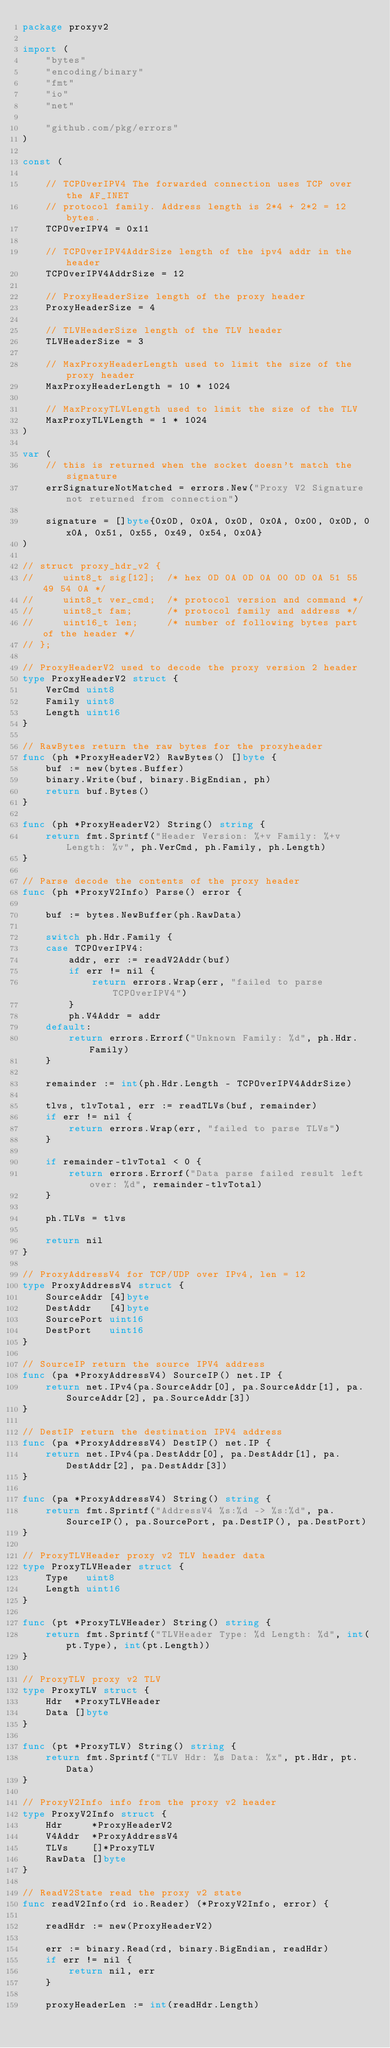Convert code to text. <code><loc_0><loc_0><loc_500><loc_500><_Go_>package proxyv2

import (
	"bytes"
	"encoding/binary"
	"fmt"
	"io"
	"net"

	"github.com/pkg/errors"
)

const (

	// TCPOverIPV4 The forwarded connection uses TCP over the AF_INET
	// protocol family. Address length is 2*4 + 2*2 = 12 bytes.
	TCPOverIPV4 = 0x11

	// TCPOverIPV4AddrSize length of the ipv4 addr in the header
	TCPOverIPV4AddrSize = 12

	// ProxyHeaderSize length of the proxy header
	ProxyHeaderSize = 4

	// TLVHeaderSize length of the TLV header
	TLVHeaderSize = 3

	// MaxProxyHeaderLength used to limit the size of the proxy header
	MaxProxyHeaderLength = 10 * 1024

	// MaxProxyTLVLength used to limit the size of the TLV
	MaxProxyTLVLength = 1 * 1024
)

var (
	// this is returned when the socket doesn't match the signature
	errSignatureNotMatched = errors.New("Proxy V2 Signature not returned from connection")

	signature = []byte{0x0D, 0x0A, 0x0D, 0x0A, 0x00, 0x0D, 0x0A, 0x51, 0x55, 0x49, 0x54, 0x0A}
)

// struct proxy_hdr_v2 {
//     uint8_t sig[12];  /* hex 0D 0A 0D 0A 00 0D 0A 51 55 49 54 0A */
//     uint8_t ver_cmd;  /* protocol version and command */
//     uint8_t fam;      /* protocol family and address */
//     uint16_t len;     /* number of following bytes part of the header */
// };

// ProxyHeaderV2 used to decode the proxy version 2 header
type ProxyHeaderV2 struct {
	VerCmd uint8
	Family uint8
	Length uint16
}

// RawBytes return the raw bytes for the proxyheader
func (ph *ProxyHeaderV2) RawBytes() []byte {
	buf := new(bytes.Buffer)
	binary.Write(buf, binary.BigEndian, ph)
	return buf.Bytes()
}

func (ph *ProxyHeaderV2) String() string {
	return fmt.Sprintf("Header Version: %+v Family: %+v Length: %v", ph.VerCmd, ph.Family, ph.Length)
}

// Parse decode the contents of the proxy header
func (ph *ProxyV2Info) Parse() error {

	buf := bytes.NewBuffer(ph.RawData)

	switch ph.Hdr.Family {
	case TCPOverIPV4:
		addr, err := readV2Addr(buf)
		if err != nil {
			return errors.Wrap(err, "failed to parse TCPOverIPV4")
		}
		ph.V4Addr = addr
	default:
		return errors.Errorf("Unknown Family: %d", ph.Hdr.Family)
	}

	remainder := int(ph.Hdr.Length - TCPOverIPV4AddrSize)

	tlvs, tlvTotal, err := readTLVs(buf, remainder)
	if err != nil {
		return errors.Wrap(err, "failed to parse TLVs")
	}

	if remainder-tlvTotal < 0 {
		return errors.Errorf("Data parse failed result left over: %d", remainder-tlvTotal)
	}

	ph.TLVs = tlvs

	return nil
}

// ProxyAddressV4 for TCP/UDP over IPv4, len = 12
type ProxyAddressV4 struct {
	SourceAddr [4]byte
	DestAddr   [4]byte
	SourcePort uint16
	DestPort   uint16
}

// SourceIP return the source IPV4 address
func (pa *ProxyAddressV4) SourceIP() net.IP {
	return net.IPv4(pa.SourceAddr[0], pa.SourceAddr[1], pa.SourceAddr[2], pa.SourceAddr[3])
}

// DestIP return the destination IPV4 address
func (pa *ProxyAddressV4) DestIP() net.IP {
	return net.IPv4(pa.DestAddr[0], pa.DestAddr[1], pa.DestAddr[2], pa.DestAddr[3])
}

func (pa *ProxyAddressV4) String() string {
	return fmt.Sprintf("AddressV4 %s:%d -> %s:%d", pa.SourceIP(), pa.SourcePort, pa.DestIP(), pa.DestPort)
}

// ProxyTLVHeader proxy v2 TLV header data
type ProxyTLVHeader struct {
	Type   uint8
	Length uint16
}

func (pt *ProxyTLVHeader) String() string {
	return fmt.Sprintf("TLVHeader Type: %d Length: %d", int(pt.Type), int(pt.Length))
}

// ProxyTLV proxy v2 TLV
type ProxyTLV struct {
	Hdr  *ProxyTLVHeader
	Data []byte
}

func (pt *ProxyTLV) String() string {
	return fmt.Sprintf("TLV Hdr: %s Data: %x", pt.Hdr, pt.Data)
}

// ProxyV2Info info from the proxy v2 header
type ProxyV2Info struct {
	Hdr     *ProxyHeaderV2
	V4Addr  *ProxyAddressV4
	TLVs    []*ProxyTLV
	RawData []byte
}

// ReadV2State read the proxy v2 state
func readV2Info(rd io.Reader) (*ProxyV2Info, error) {

	readHdr := new(ProxyHeaderV2)

	err := binary.Read(rd, binary.BigEndian, readHdr)
	if err != nil {
		return nil, err
	}

	proxyHeaderLen := int(readHdr.Length)
</code> 